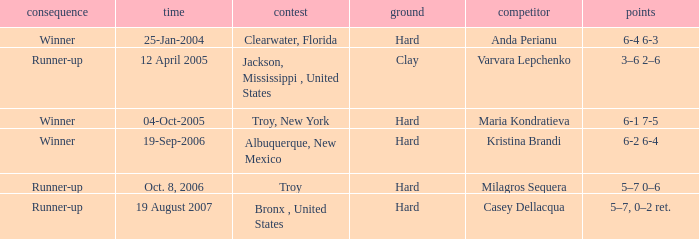What was the outcome of the game played on 19-Sep-2006? Winner. 